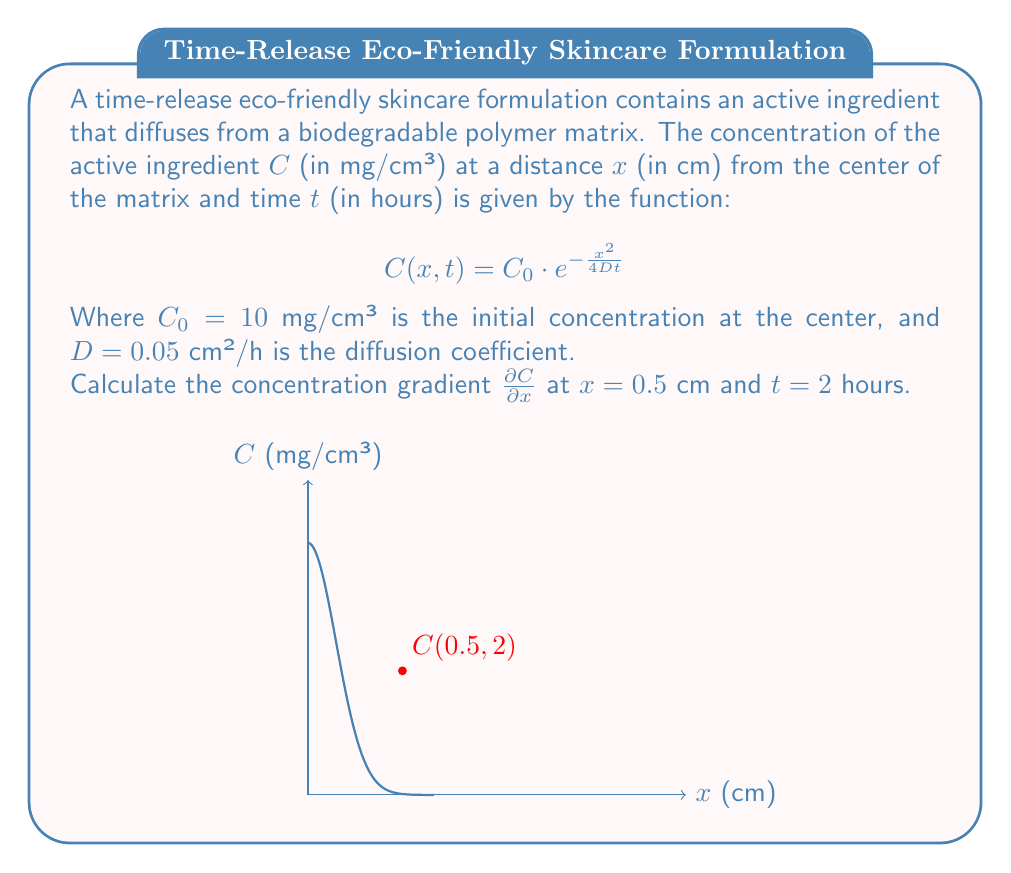Give your solution to this math problem. To find the concentration gradient, we need to partially differentiate $C(x,t)$ with respect to $x$ and then evaluate it at the given points. Let's proceed step-by-step:

1) First, let's partially differentiate $C(x,t)$ with respect to $x$:

   $$\frac{\partial C}{\partial x} = \frac{\partial}{\partial x} \left(C_0 \cdot e^{-\frac{x^2}{4Dt}}\right)$$

2) Using the chain rule:

   $$\frac{\partial C}{\partial x} = C_0 \cdot e^{-\frac{x^2}{4Dt}} \cdot \frac{\partial}{\partial x}\left(-\frac{x^2}{4Dt}\right)$$

3) Simplify:

   $$\frac{\partial C}{\partial x} = C_0 \cdot e^{-\frac{x^2}{4Dt}} \cdot \left(-\frac{x}{2Dt}\right)$$

4) Now, let's substitute the given values: $C_0 = 10$ mg/cm³, $D = 0.05$ cm²/h, $x = 0.5$ cm, and $t = 2$ h:

   $$\frac{\partial C}{\partial x} = 10 \cdot e^{-\frac{(0.5)^2}{4(0.05)(2)}} \cdot \left(-\frac{0.5}{2(0.05)(2)}\right)$$

5) Simplify the exponent:

   $$\frac{\partial C}{\partial x} = 10 \cdot e^{-\frac{0.25}{0.4}} \cdot \left(-\frac{0.5}{0.2}\right)$$

6) Calculate:

   $$\frac{\partial C}{\partial x} = 10 \cdot e^{-0.625} \cdot (-2.5)$$

7) Evaluate:

   $$\frac{\partial C}{\partial x} \approx 10 \cdot 0.5353 \cdot (-2.5) \approx -13.38$$

The negative sign indicates that the concentration decreases as we move away from the center of the matrix.
Answer: $-13.38$ mg/cm⁴ 